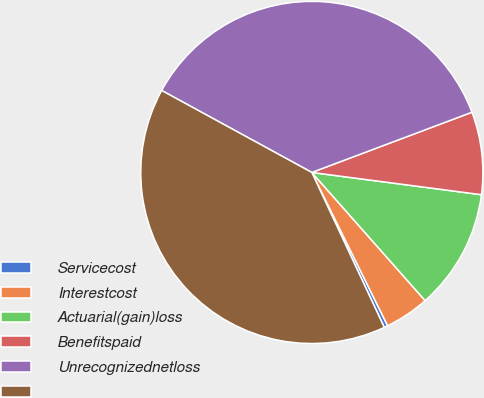Convert chart to OTSL. <chart><loc_0><loc_0><loc_500><loc_500><pie_chart><fcel>Servicecost<fcel>Interestcost<fcel>Actuarial(gain)loss<fcel>Benefitspaid<fcel>Unrecognizednetloss<fcel>Unnamed: 5<nl><fcel>0.35%<fcel>4.21%<fcel>11.4%<fcel>7.8%<fcel>36.32%<fcel>39.91%<nl></chart> 